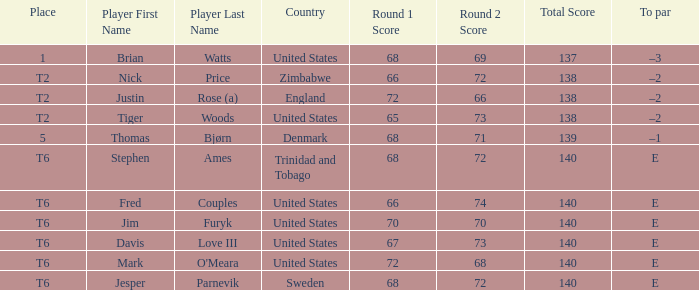The player for which country had a score of 66-72=138? Zimbabwe. 